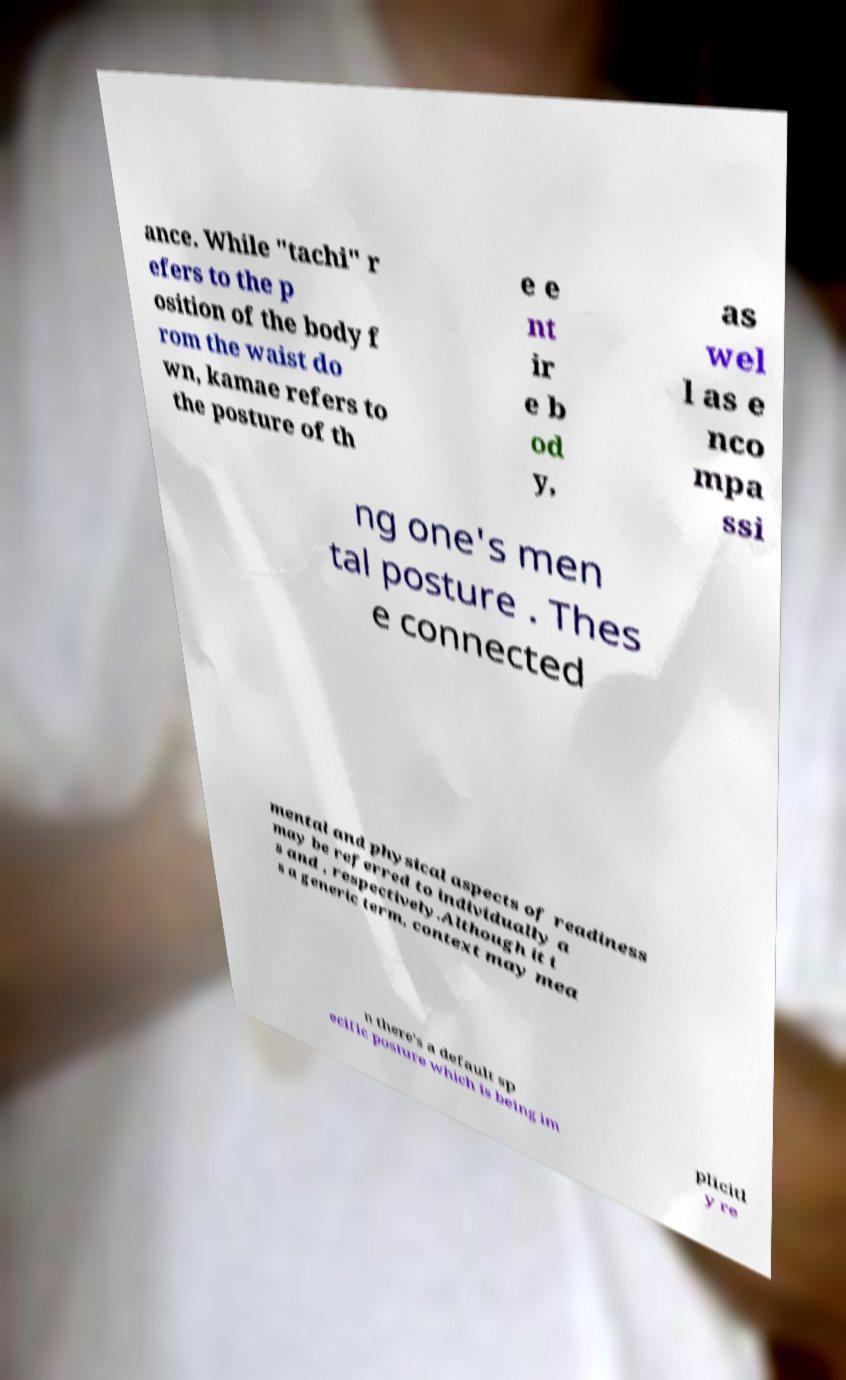Can you read and provide the text displayed in the image?This photo seems to have some interesting text. Can you extract and type it out for me? ance. While "tachi" r efers to the p osition of the body f rom the waist do wn, kamae refers to the posture of th e e nt ir e b od y, as wel l as e nco mpa ssi ng one's men tal posture . Thes e connected mental and physical aspects of readiness may be referred to individually a s and , respectively.Although it i s a generic term, context may mea n there's a default sp ecific posture which is being im plicitl y re 